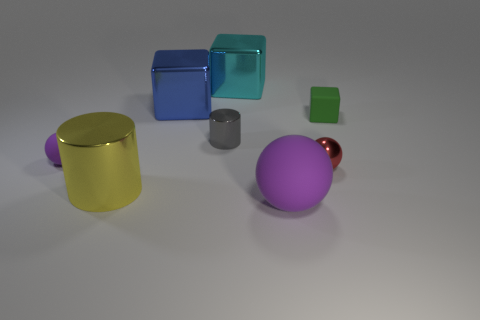Add 1 metallic things. How many objects exist? 9 Subtract all cubes. How many objects are left? 5 Add 4 green rubber cubes. How many green rubber cubes are left? 5 Add 5 big purple blocks. How many big purple blocks exist? 5 Subtract 0 gray cubes. How many objects are left? 8 Subtract all large cyan metallic blocks. Subtract all cyan blocks. How many objects are left? 6 